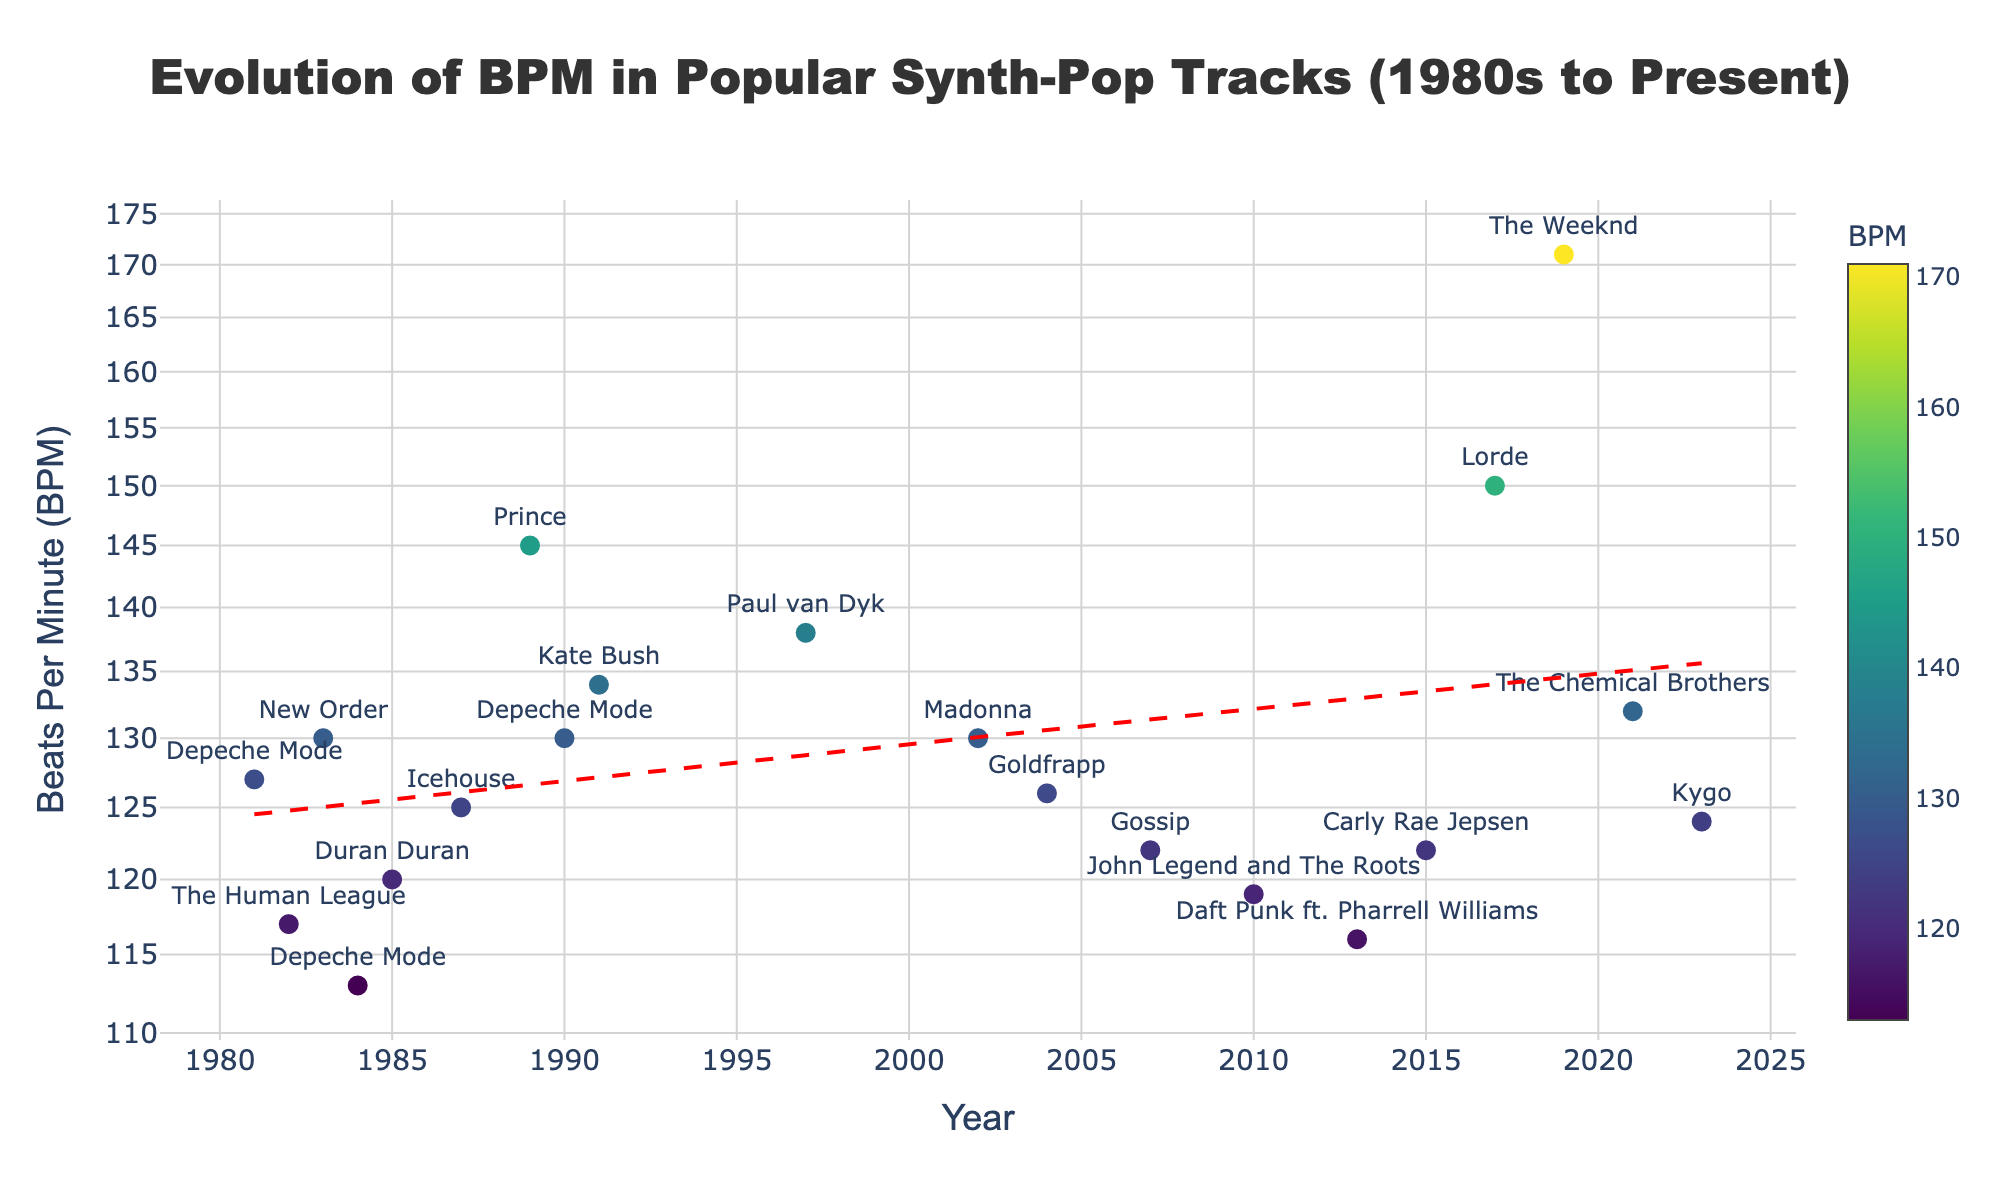What's the title of the figure? The title is presented at the top of the figure in a bold font. The title reads "Evolution of BPM in Popular Synth-Pop Tracks (1980s to Present)".
Answer: Evolution of BPM in Popular Synth-Pop Tracks (1980s to Present) What are the x-axis and y-axis representing? The x-axis, labeled "Year," represents the years from the 1980s to the present. The y-axis, labeled "Beats Per Minute (BPM)," represents the BPM values and is on a log scale.
Answer: Year and Beats Per Minute (BPM) Which track has the highest BPM in the plot? The hoverlabel on the top-most data point shows the track "Blinding Lights" by The Weeknd with a BPM of 171, which is the highest BPM on the plot.
Answer: Blinding Lights How many tracks are there in the plot? Counting the number of marker points shown in the figure gives the total number of tracks represented. There are 19 marker points.
Answer: 19 Which year has the lowest BPM and what is the value? The plot shows the point with the lowest BPM at the bottom, marked "Enjoy the Silence" by Depeche Mode in 1984 with a BPM of 113.
Answer: 1984, 113 BPM What is the trend of BPM over the years? The red dashed line represents the trend line. It shows a slight upward trend, indicating that BPM tends to increase slightly over the years.
Answer: Slight upward trend Which artist appears most frequently on the plot? By checking the text labels next to the markers, "Depeche Mode" appears most frequently with three tracks: "Just Can't Get Enough," "Enjoy the Silence," and "Personal Jesus."
Answer: Depeche Mode How does the BPM of "Get Lucky" (Daft Punk) compare to "Run Away with Me" (Carly Rae Jepsen)? By locating the markers for the years 2013 and 2015, "Get Lucky" has a BPM of 116, and "Run Away with Me" has a BPM of 122. "Run Away with Me" has a higher BPM.
Answer: Run Away with Me has a higher BPM What is the approximate BPM range in the 2000s (2000-2009)? Looking at the markers for the years 2002, 2004, and 2007, the BPM values are 130, 126, and 122 respectively. The range is from 122 to 130 BPM.
Answer: 122 to 130 BPM Identify the track with a BPM of 130 released after the year 2000. There are two tracks with a BPM of 130 released after 2000. They are "Frozen" by Madonna in 2002 and "Personal Jesus" by Depeche Mode in 1990.
Answer: Frozen 